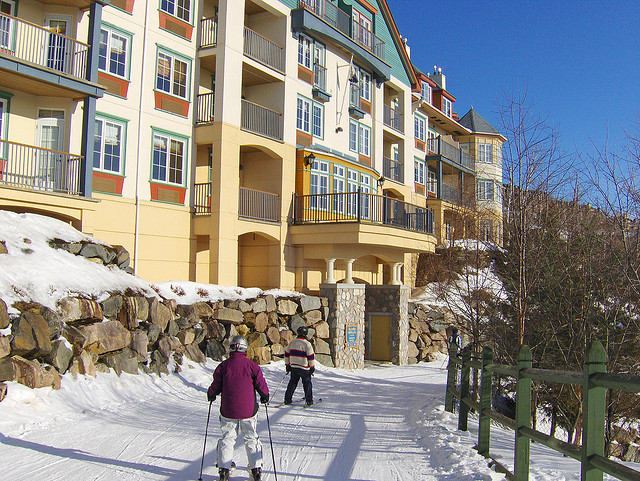What type of building is shown in the background? The building in the background appears to be a residential or resort-style building, likely associated with the nearby skiing facilities given its proximity to the ski path. 